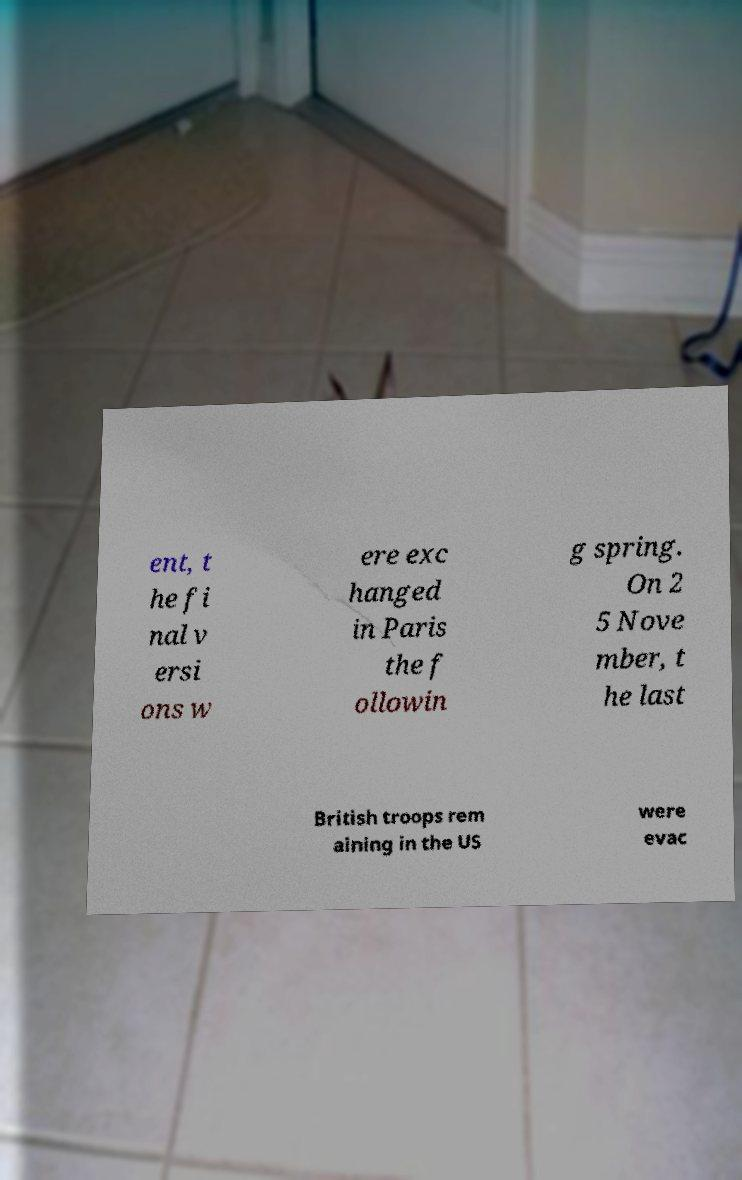I need the written content from this picture converted into text. Can you do that? ent, t he fi nal v ersi ons w ere exc hanged in Paris the f ollowin g spring. On 2 5 Nove mber, t he last British troops rem aining in the US were evac 